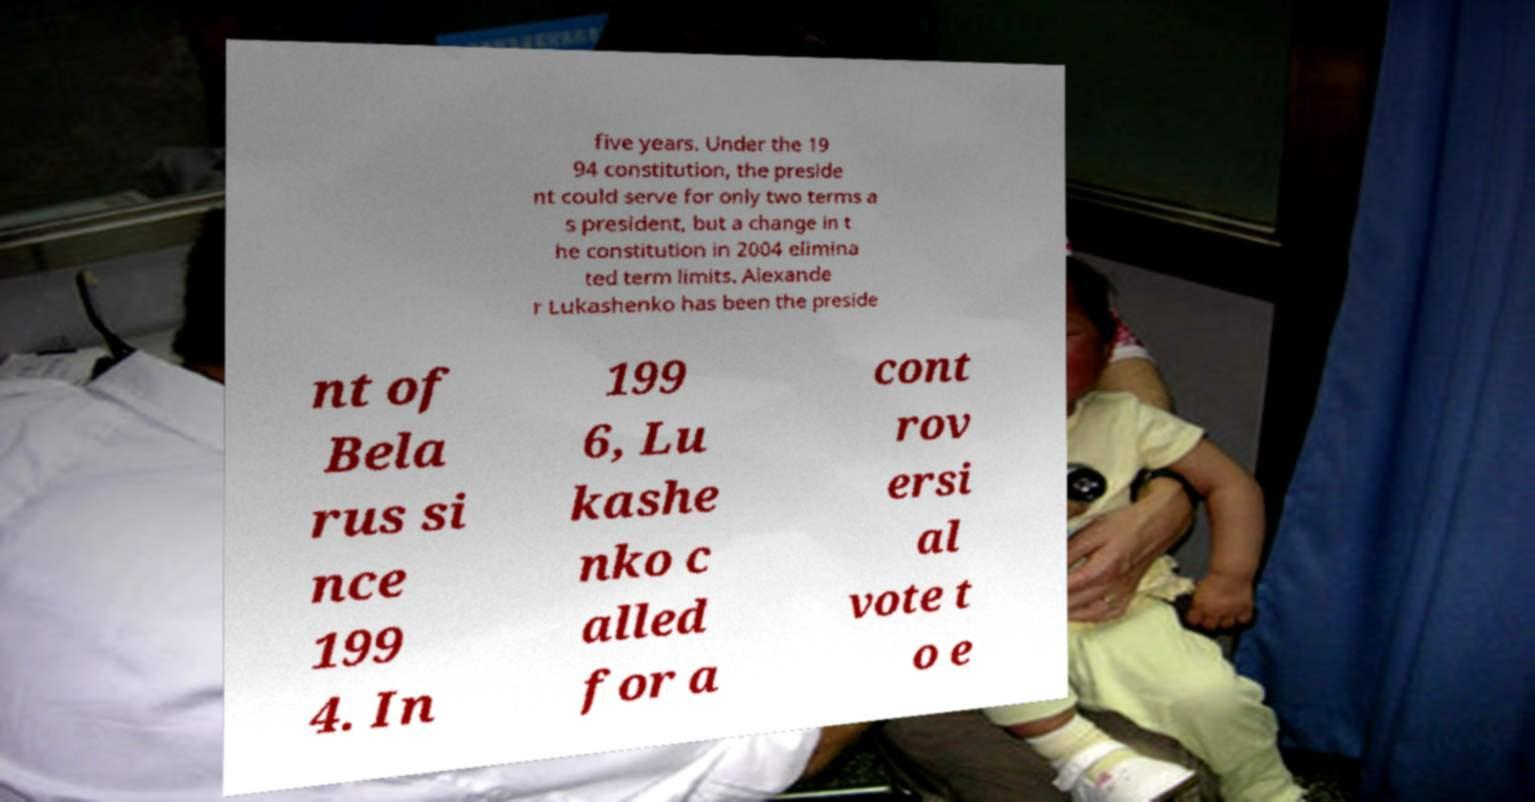Can you read and provide the text displayed in the image?This photo seems to have some interesting text. Can you extract and type it out for me? five years. Under the 19 94 constitution, the preside nt could serve for only two terms a s president, but a change in t he constitution in 2004 elimina ted term limits. Alexande r Lukashenko has been the preside nt of Bela rus si nce 199 4. In 199 6, Lu kashe nko c alled for a cont rov ersi al vote t o e 